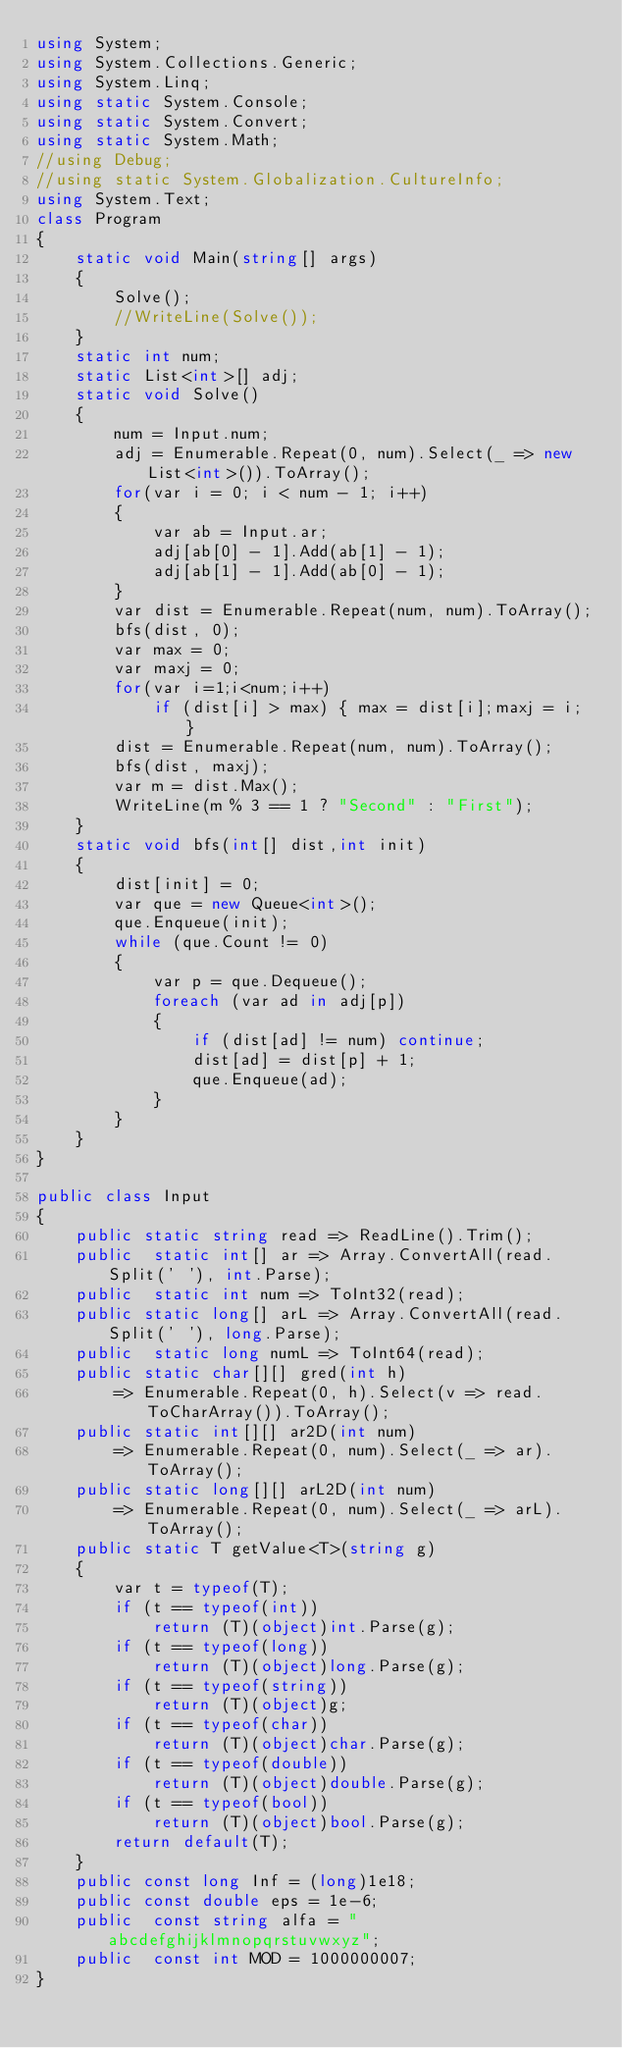Convert code to text. <code><loc_0><loc_0><loc_500><loc_500><_C#_>using System;
using System.Collections.Generic;
using System.Linq;
using static System.Console;
using static System.Convert;
using static System.Math;
//using Debug;
//using static System.Globalization.CultureInfo;
using System.Text;
class Program
{
    static void Main(string[] args)
    {
        Solve();
        //WriteLine(Solve());
    }
    static int num;
    static List<int>[] adj;
    static void Solve()
    {
        num = Input.num;
        adj = Enumerable.Repeat(0, num).Select(_ => new List<int>()).ToArray();
        for(var i = 0; i < num - 1; i++)
        {
            var ab = Input.ar;
            adj[ab[0] - 1].Add(ab[1] - 1);
            adj[ab[1] - 1].Add(ab[0] - 1);
        }
        var dist = Enumerable.Repeat(num, num).ToArray();
        bfs(dist, 0);
        var max = 0;
        var maxj = 0;
        for(var i=1;i<num;i++)
            if (dist[i] > max) { max = dist[i];maxj = i; }
        dist = Enumerable.Repeat(num, num).ToArray();
        bfs(dist, maxj);
        var m = dist.Max();
        WriteLine(m % 3 == 1 ? "Second" : "First");
    }
    static void bfs(int[] dist,int init)
    {
        dist[init] = 0;
        var que = new Queue<int>();
        que.Enqueue(init);
        while (que.Count != 0)
        {
            var p = que.Dequeue();
            foreach (var ad in adj[p])
            {
                if (dist[ad] != num) continue;
                dist[ad] = dist[p] + 1;
                que.Enqueue(ad);
            }
        }
    }
}

public class Input
{
    public static string read => ReadLine().Trim();
    public  static int[] ar => Array.ConvertAll(read.Split(' '), int.Parse);
    public  static int num => ToInt32(read);
    public static long[] arL => Array.ConvertAll(read.Split(' '), long.Parse);
    public  static long numL => ToInt64(read);
    public static char[][] gred(int h) 
        => Enumerable.Repeat(0, h).Select(v => read.ToCharArray()).ToArray();
    public static int[][] ar2D(int num)
        => Enumerable.Repeat(0, num).Select(_ => ar).ToArray();
    public static long[][] arL2D(int num)
        => Enumerable.Repeat(0, num).Select(_ => arL).ToArray();
    public static T getValue<T>(string g)
    {
        var t = typeof(T);
        if (t == typeof(int))
            return (T)(object)int.Parse(g);
        if (t == typeof(long))
            return (T)(object)long.Parse(g);
        if (t == typeof(string))
            return (T)(object)g;
        if (t == typeof(char))
            return (T)(object)char.Parse(g);
        if (t == typeof(double))
            return (T)(object)double.Parse(g);
        if (t == typeof(bool))
            return (T)(object)bool.Parse(g);
        return default(T);
    }
    public const long Inf = (long)1e18;
    public const double eps = 1e-6;
    public  const string alfa = "abcdefghijklmnopqrstuvwxyz";
    public  const int MOD = 1000000007;
}</code> 